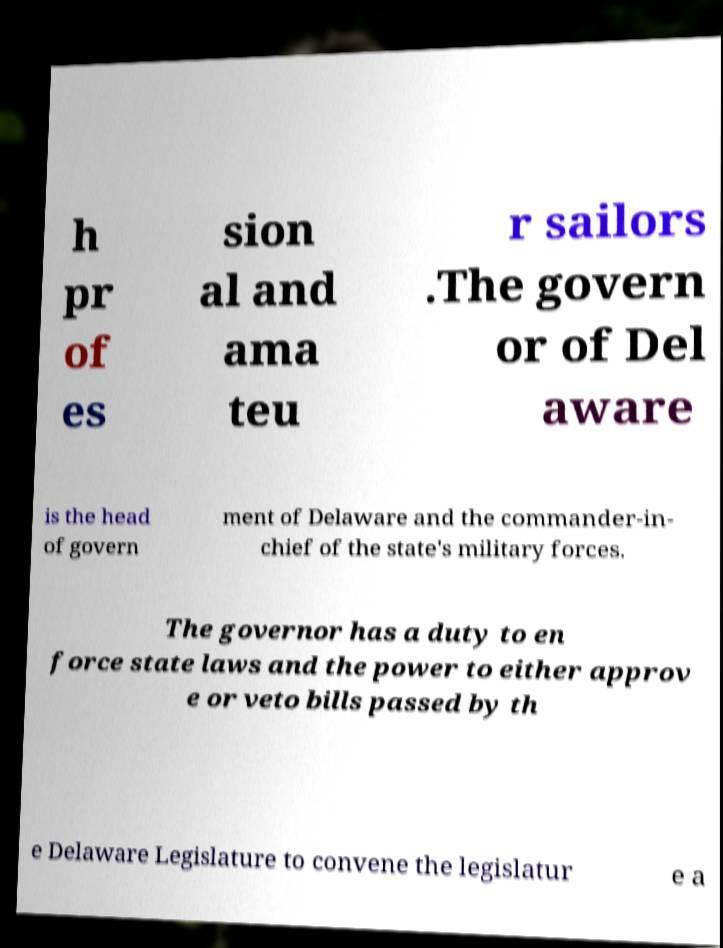For documentation purposes, I need the text within this image transcribed. Could you provide that? h pr of es sion al and ama teu r sailors .The govern or of Del aware is the head of govern ment of Delaware and the commander-in- chief of the state's military forces. The governor has a duty to en force state laws and the power to either approv e or veto bills passed by th e Delaware Legislature to convene the legislatur e a 